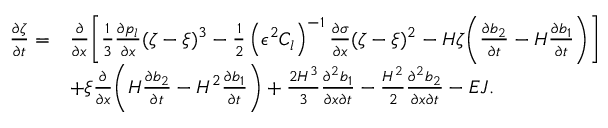Convert formula to latex. <formula><loc_0><loc_0><loc_500><loc_500>\begin{array} { r l } { \frac { \partial \zeta } { \partial t } = } & { \frac { \partial } { \partial x } \left [ \frac { 1 } { 3 } \frac { \partial p _ { l } } { \partial x } ( \zeta - \xi ) ^ { 3 } - \frac { 1 } { 2 } \left ( \epsilon ^ { 2 } C _ { l } \right ) ^ { - 1 } \frac { \partial \sigma } { \partial x } ( \zeta - \xi ) ^ { 2 } - H \zeta \left ( \frac { \partial b _ { 2 } } { \partial t } - H \frac { \partial b _ { 1 } } { \partial t } \right ) \right ] } \\ & { + \xi \frac { \partial } { \partial x } \left ( H \frac { \partial b _ { 2 } } { \partial t } - H ^ { 2 } \frac { \partial b _ { 1 } } { \partial t } \right ) + \frac { 2 H ^ { 3 } } { 3 } \frac { \partial ^ { 2 } b _ { 1 } } { \partial x \partial t } - \frac { H ^ { 2 } } { 2 } \frac { \partial ^ { 2 } b _ { 2 } } { \partial x \partial t } - E J . } \end{array}</formula> 